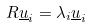<formula> <loc_0><loc_0><loc_500><loc_500>R \underline { u } _ { i } = \lambda _ { i } \underline { u } _ { i }</formula> 